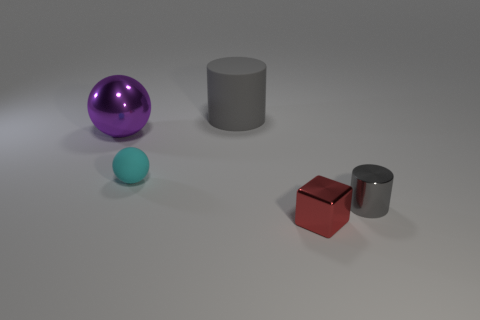Subtract all green blocks. Subtract all red cylinders. How many blocks are left? 1 Subtract all brown cylinders. How many gray spheres are left? 0 Add 2 grays. How many small things exist? 0 Subtract all big matte things. Subtract all large purple balls. How many objects are left? 3 Add 2 small blocks. How many small blocks are left? 3 Add 1 small green shiny spheres. How many small green shiny spheres exist? 1 Add 5 purple shiny spheres. How many objects exist? 10 Subtract all purple spheres. How many spheres are left? 1 Subtract 0 blue blocks. How many objects are left? 5 Subtract all blocks. How many objects are left? 4 